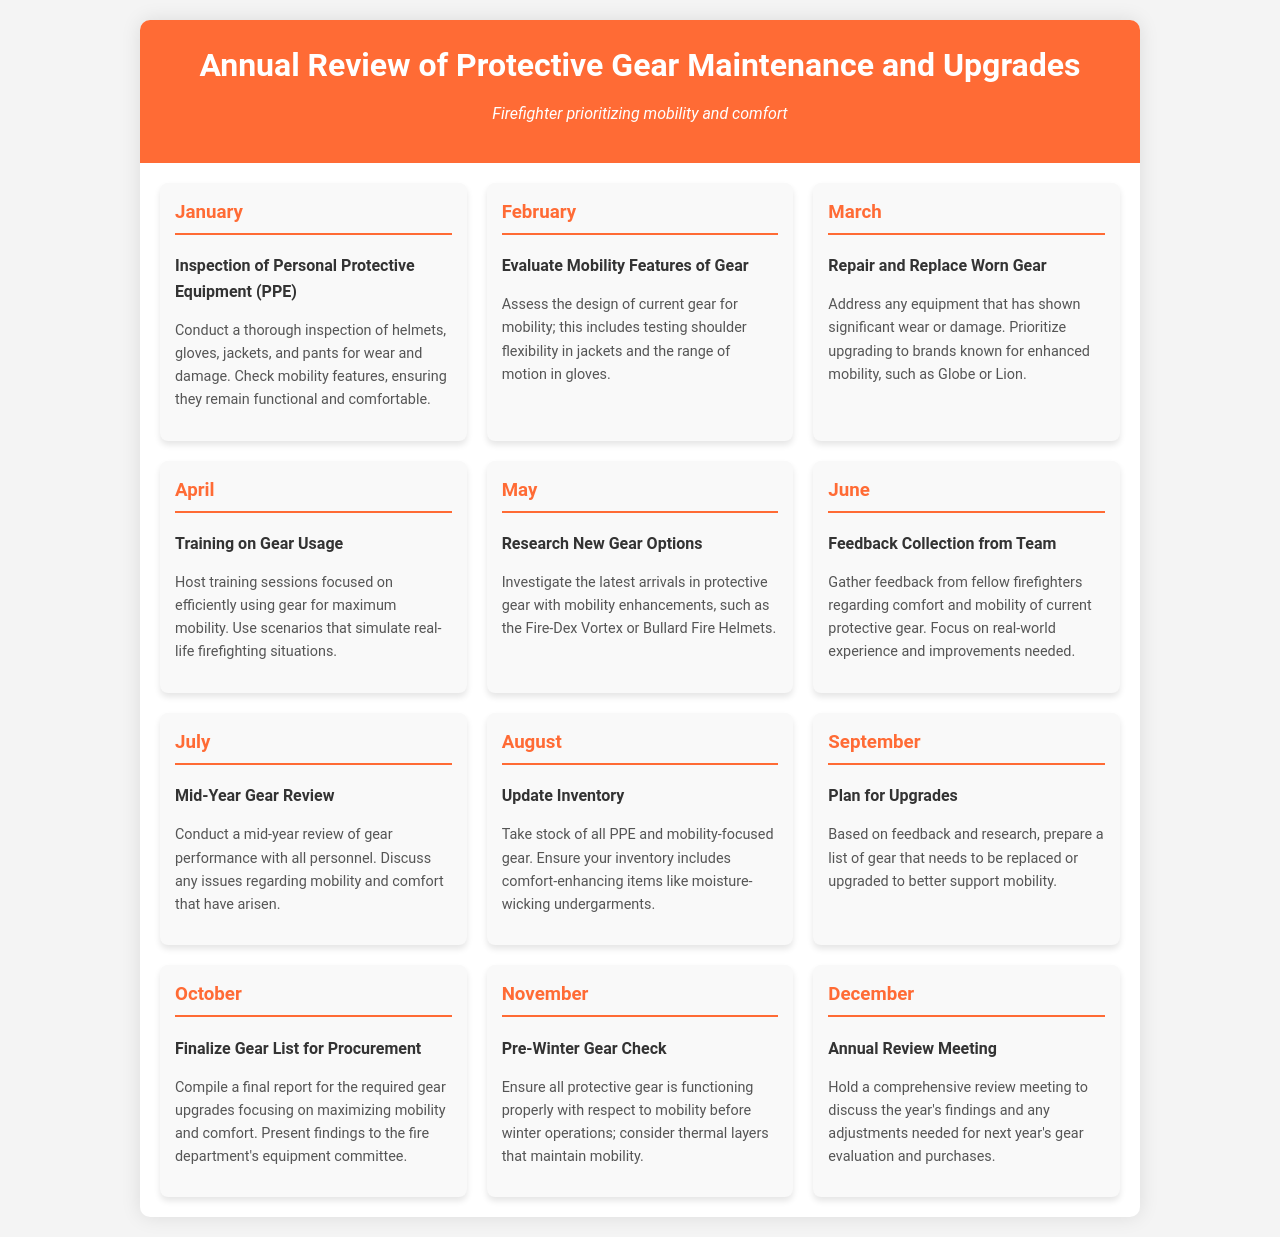What is the first activity in January? The first activity listed in January is the inspection of Personal Protective Equipment.
Answer: Inspection of Personal Protective Equipment (PPE) What gear brand is prioritized for upgrades in March? The document mentions prioritizing brands known for enhanced mobility in March.
Answer: Globe or Lion How many months include a review of gear? The schedule features two months dedicated to review activities: July and December.
Answer: Two Which month focuses on evaluating mobility features? The evaluation of mobility features takes place in February.
Answer: February What is the primary focus of the April training sessions? The training sessions in April focus on efficiently using gear for maximum mobility.
Answer: Maximum mobility Which month involves gathering feedback from team members? Feedback collection from team members occurs in June.
Answer: June What should be included in the inventory update in August? The inventory update in August should ensure it includes comfort-enhancing items.
Answer: Moisture-wicking undergarments During which month is the gear list for procurement finalized? The gear list for procurement is finalized in October.
Answer: October What is the last activity of the year? The last activity of the year is the Annual Review Meeting.
Answer: Annual Review Meeting 